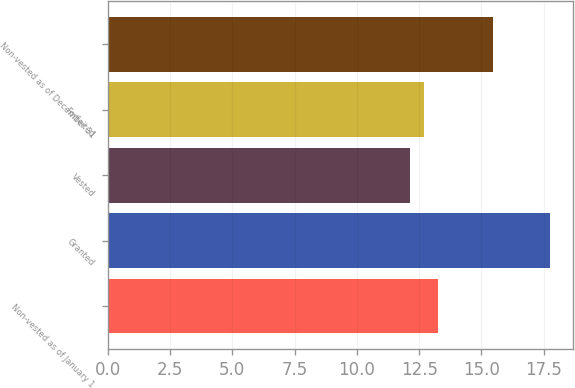<chart> <loc_0><loc_0><loc_500><loc_500><bar_chart><fcel>Non-vested as of January 1<fcel>Granted<fcel>Vested<fcel>Forfeited<fcel>Non-vested as of December 31<nl><fcel>13.27<fcel>17.77<fcel>12.15<fcel>12.71<fcel>15.47<nl></chart> 